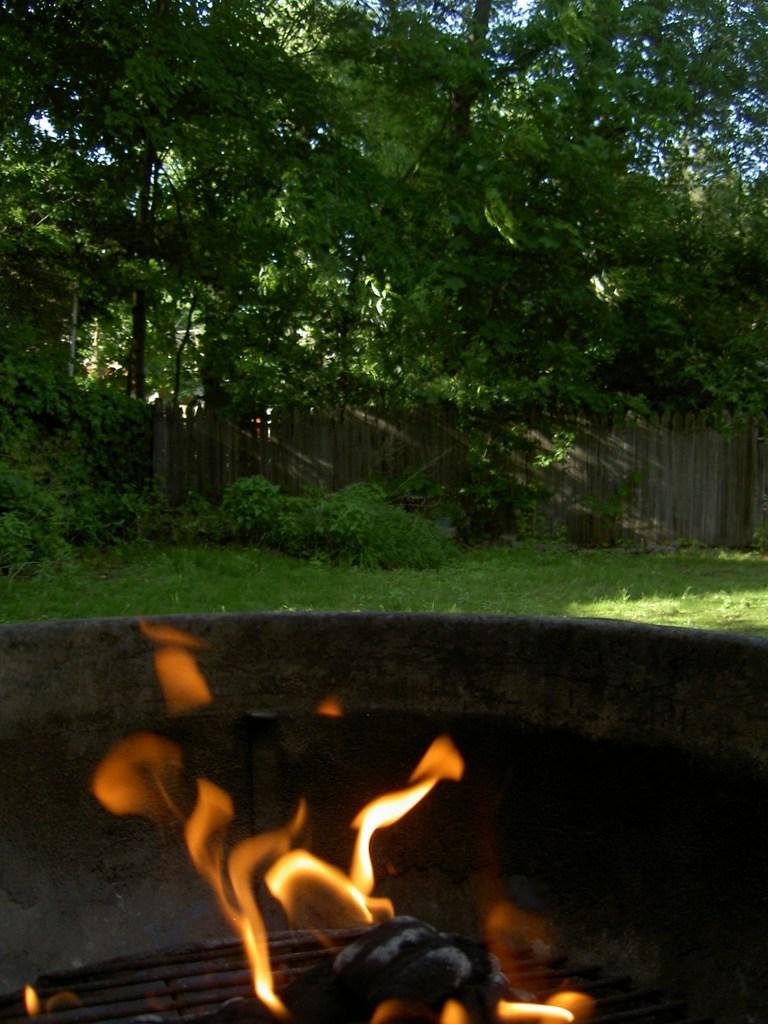How would you summarize this image in a sentence or two? There is a grill with fire. In the back there is grass, plants and trees. Also there is a wooden fencing. 